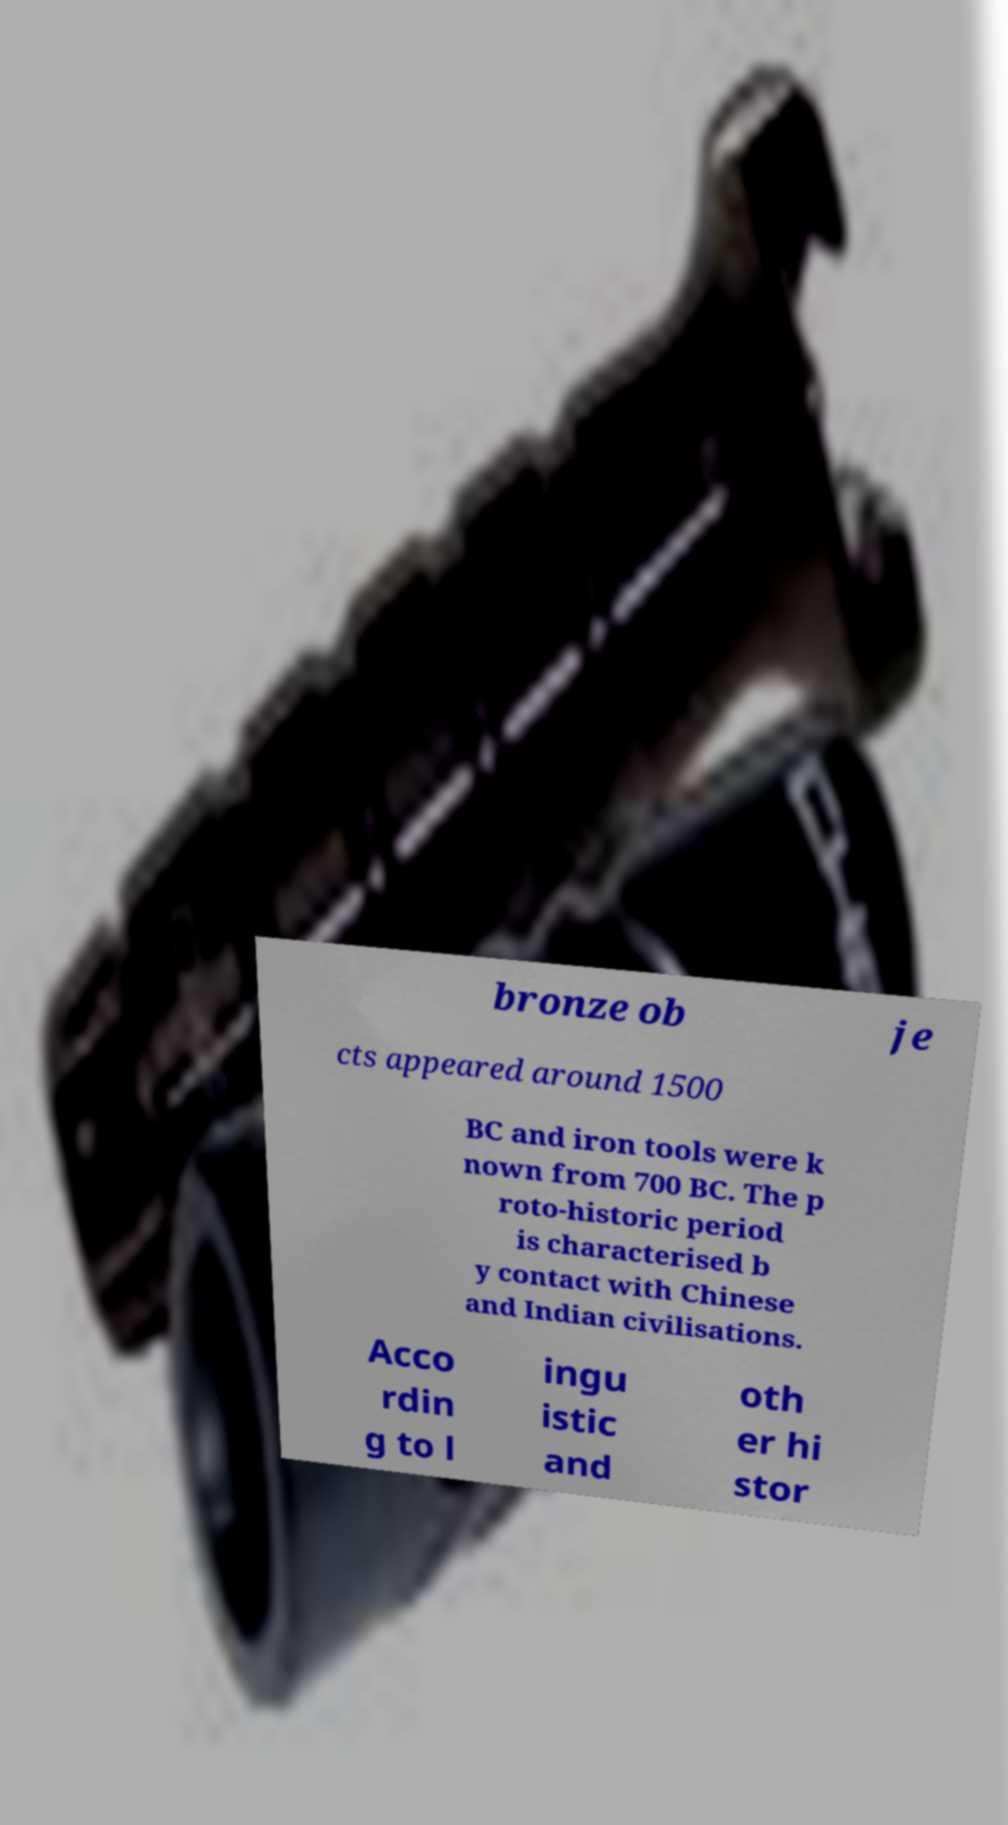Can you accurately transcribe the text from the provided image for me? bronze ob je cts appeared around 1500 BC and iron tools were k nown from 700 BC. The p roto-historic period is characterised b y contact with Chinese and Indian civilisations. Acco rdin g to l ingu istic and oth er hi stor 